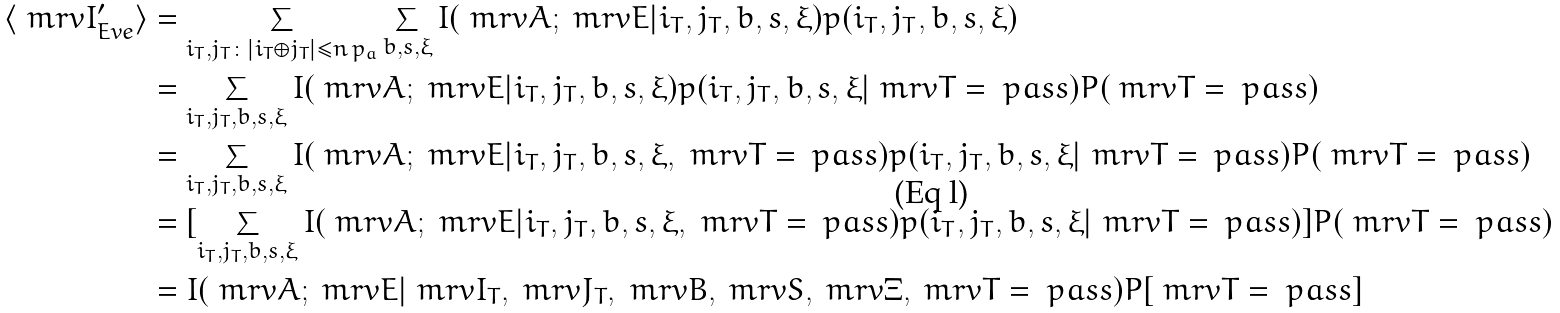<formula> <loc_0><loc_0><loc_500><loc_500>\langle \ m r v { I } ^ { \prime } _ { E v e } \rangle & = \sum _ { i _ { T } , j _ { T } \colon | i _ { T } \oplus j _ { T } | \leq n \, p _ { a } } \sum _ { b , s , \xi } I ( \ m r v { A } ; \ m r v { E } | i _ { T } , j _ { T } , b , s , \xi ) p ( i _ { T } , j _ { T } , b , s , \xi ) \\ & = \sum _ { i _ { T } , j _ { T } , b , s , \xi } I ( \ m r v { A } ; \ m r v { E } | i _ { T } , j _ { T } , b , s , \xi ) p ( i _ { T } , j _ { T } , b , s , \xi | \ m r v { T } = \ p a s s ) P ( \ m r v { T } = \ p a s s ) \\ & = \sum _ { i _ { T } , j _ { T } , b , s , \xi } I ( \ m r v { A } ; \ m r v { E } | i _ { T } , j _ { T } , b , s , \xi , \ m r v { T } = \ p a s s ) p ( i _ { T } , j _ { T } , b , s , \xi | \ m r v { T } = \ p a s s ) P ( \ m r v { T } = \ p a s s ) \\ & = [ \sum _ { i _ { T } , j _ { T } , b , s , \xi } I ( \ m r v { A } ; \ m r v { E } | i _ { T } , j _ { T } , b , s , \xi , \ m r v { T } = \ p a s s ) p ( i _ { T } , j _ { T } , b , s , \xi | \ m r v { T } = \ p a s s ) ] P ( \ m r v { T } = \ p a s s ) \\ & = I ( \ m r v { A } ; \ m r v { E } | \ m r v { I } _ { T } , \ m r v { J } _ { T } , \ m r v { B } , \ m r v { S } , \ m r v { \Xi } , \ m r v { T } = \ p a s s ) P [ \ m r v { T } = \ p a s s ]</formula> 